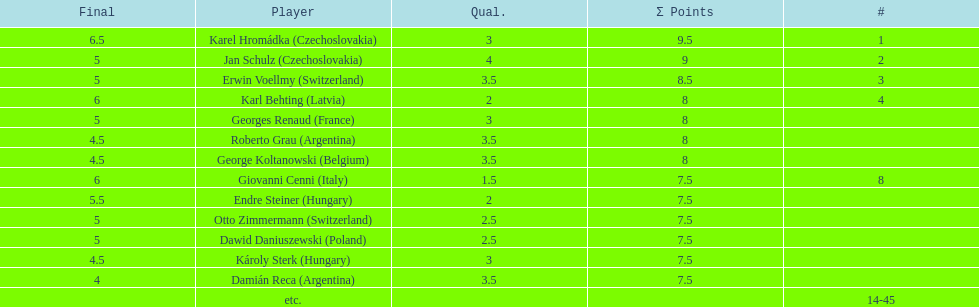Which player had the largest number of &#931; points? Karel Hromádka. 